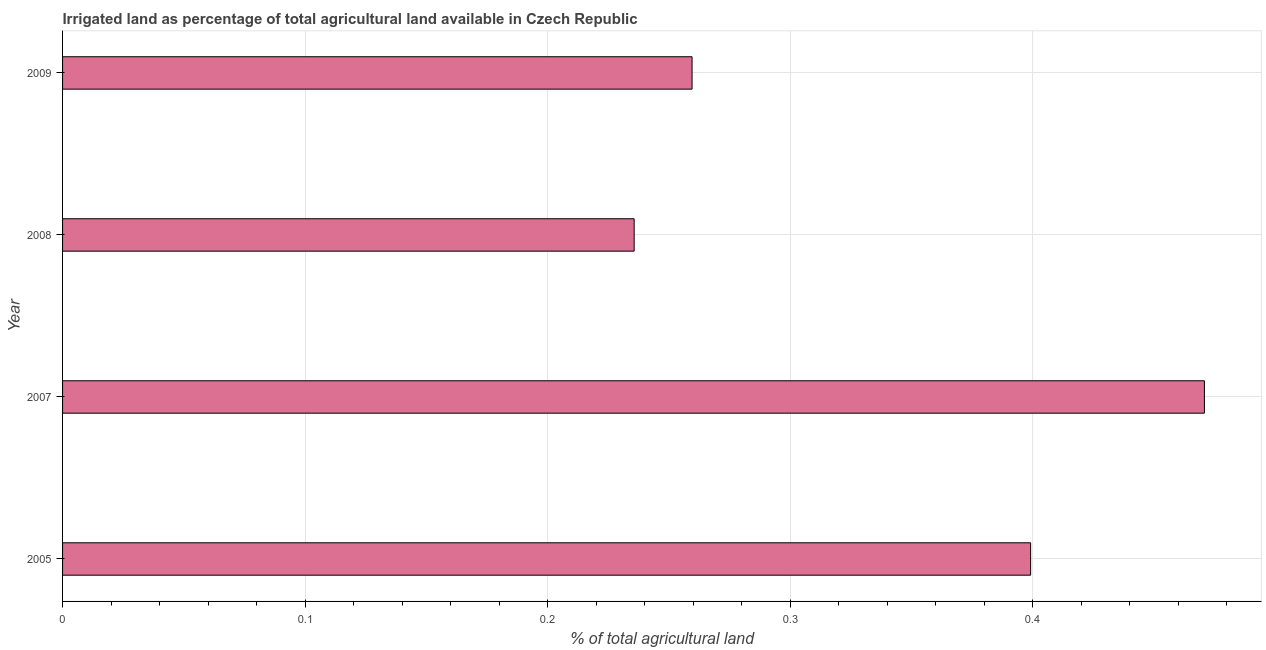What is the title of the graph?
Provide a short and direct response. Irrigated land as percentage of total agricultural land available in Czech Republic. What is the label or title of the X-axis?
Give a very brief answer. % of total agricultural land. What is the percentage of agricultural irrigated land in 2005?
Ensure brevity in your answer.  0.4. Across all years, what is the maximum percentage of agricultural irrigated land?
Provide a short and direct response. 0.47. Across all years, what is the minimum percentage of agricultural irrigated land?
Provide a short and direct response. 0.24. What is the sum of the percentage of agricultural irrigated land?
Provide a succinct answer. 1.36. What is the difference between the percentage of agricultural irrigated land in 2008 and 2009?
Give a very brief answer. -0.02. What is the average percentage of agricultural irrigated land per year?
Provide a short and direct response. 0.34. What is the median percentage of agricultural irrigated land?
Your answer should be very brief. 0.33. In how many years, is the percentage of agricultural irrigated land greater than 0.36 %?
Your answer should be compact. 2. Do a majority of the years between 2008 and 2005 (inclusive) have percentage of agricultural irrigated land greater than 0.34 %?
Give a very brief answer. Yes. What is the ratio of the percentage of agricultural irrigated land in 2005 to that in 2008?
Your response must be concise. 1.69. What is the difference between the highest and the second highest percentage of agricultural irrigated land?
Offer a terse response. 0.07. What is the difference between the highest and the lowest percentage of agricultural irrigated land?
Ensure brevity in your answer.  0.24. In how many years, is the percentage of agricultural irrigated land greater than the average percentage of agricultural irrigated land taken over all years?
Offer a very short reply. 2. How many years are there in the graph?
Provide a short and direct response. 4. Are the values on the major ticks of X-axis written in scientific E-notation?
Make the answer very short. No. What is the % of total agricultural land of 2005?
Give a very brief answer. 0.4. What is the % of total agricultural land in 2007?
Ensure brevity in your answer.  0.47. What is the % of total agricultural land in 2008?
Your answer should be compact. 0.24. What is the % of total agricultural land of 2009?
Your response must be concise. 0.26. What is the difference between the % of total agricultural land in 2005 and 2007?
Your response must be concise. -0.07. What is the difference between the % of total agricultural land in 2005 and 2008?
Keep it short and to the point. 0.16. What is the difference between the % of total agricultural land in 2005 and 2009?
Give a very brief answer. 0.14. What is the difference between the % of total agricultural land in 2007 and 2008?
Offer a very short reply. 0.24. What is the difference between the % of total agricultural land in 2007 and 2009?
Your answer should be very brief. 0.21. What is the difference between the % of total agricultural land in 2008 and 2009?
Ensure brevity in your answer.  -0.02. What is the ratio of the % of total agricultural land in 2005 to that in 2007?
Ensure brevity in your answer.  0.85. What is the ratio of the % of total agricultural land in 2005 to that in 2008?
Your answer should be compact. 1.69. What is the ratio of the % of total agricultural land in 2005 to that in 2009?
Your answer should be very brief. 1.54. What is the ratio of the % of total agricultural land in 2007 to that in 2008?
Provide a succinct answer. 2. What is the ratio of the % of total agricultural land in 2007 to that in 2009?
Give a very brief answer. 1.81. What is the ratio of the % of total agricultural land in 2008 to that in 2009?
Your response must be concise. 0.91. 